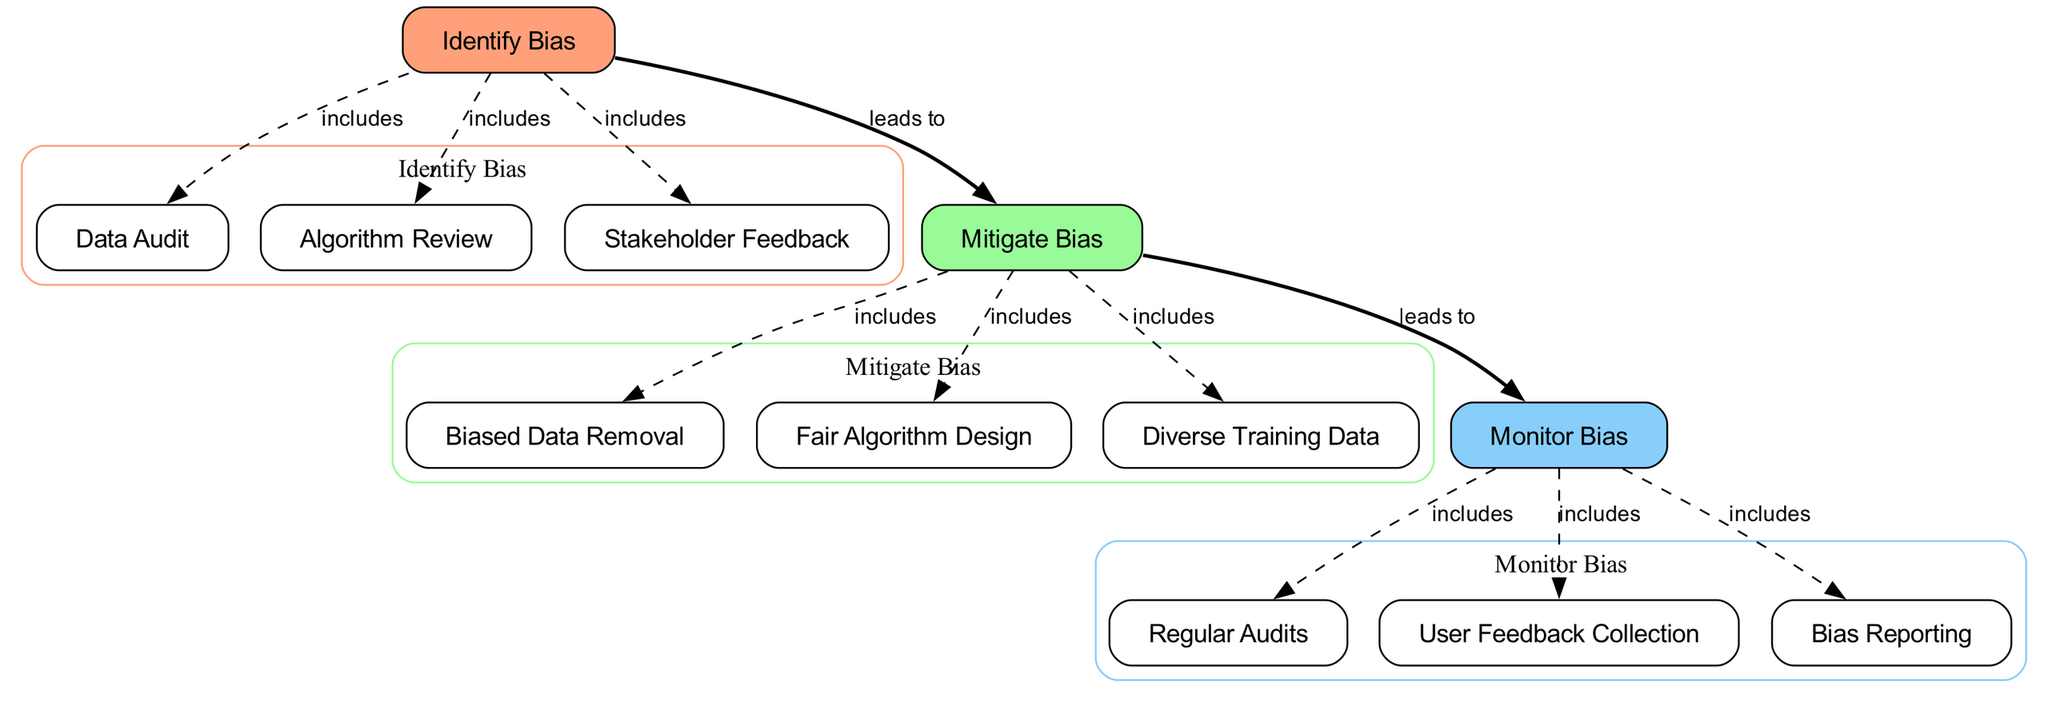What is the first step in the bias identification process? The diagram indicates that the first node in the "Identify Bias" cluster is "Identify Bias," which encompasses methods of detecting bias in AI job matching algorithms.
Answer: Identify Bias How many nodes are in the "Mitigate Bias" cluster? The "Mitigate Bias" cluster contains three nodes: "Biased Data Removal," "Fair Algorithm Design," and "Diverse Training Data." Therefore, there are three nodes in this cluster.
Answer: 3 Which node leads to the "Monitor Bias" process? According to the diagram, there is an edge labeled "leads to" that connects "Mitigate Bias" to "Monitor Bias," indicating that the mitigation of bias directly leads to monitoring.
Answer: Mitigate Bias What type of edge connects "identify_bias" to "data_audit"? The edge that connects "identify_bias" to "data_audit" is labeled "includes" and has a dashed style, showing that "data_audit" is part of the "Identify Bias" process.
Answer: includes What feedback mechanism is present in the "Monitor Bias" cluster? The "Monitor Bias" cluster includes the node "User Feedback Collection," which indicates that feedback from end-users is a feedback mechanism designed for monitoring biases in AI systems.
Answer: User Feedback Collection Which strategy is included in both "Mitigate Bias" and "Monitor Bias"? The strategy that appears in both clusters is indicative of ongoing evaluation, linking "Monitor Bias" back to processes that stem from mitigating biases, which is represented by the overall monitoring of AI systems.
Answer: Monitor Bias What does the "Stakeholder Feedback" node represent in the identification process? The "Stakeholder Feedback" node illustrates the gathering of insights from affected groups and experts, playing a crucial role in identifying any potential biases within the job matching algorithms.
Answer: Stakeholder Feedback What is the main purpose of the "Regular Audits" node? The "Regular Audits" node is focused on conducting periodic evaluations of AI system performance to ensure fairness and identify any biases that may arise over time.
Answer: Regular Audits 